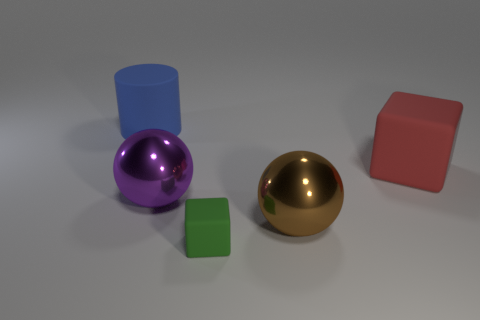Subtract all brown balls. How many balls are left? 1 Add 2 tiny purple objects. How many objects exist? 7 Subtract 1 blocks. How many blocks are left? 1 Subtract all gray balls. How many yellow cubes are left? 0 Subtract all cubes. How many objects are left? 3 Subtract all brown blocks. Subtract all purple cylinders. How many blocks are left? 2 Subtract all big metal balls. Subtract all green matte objects. How many objects are left? 2 Add 1 large cylinders. How many large cylinders are left? 2 Add 5 green matte cubes. How many green matte cubes exist? 6 Subtract 0 yellow balls. How many objects are left? 5 